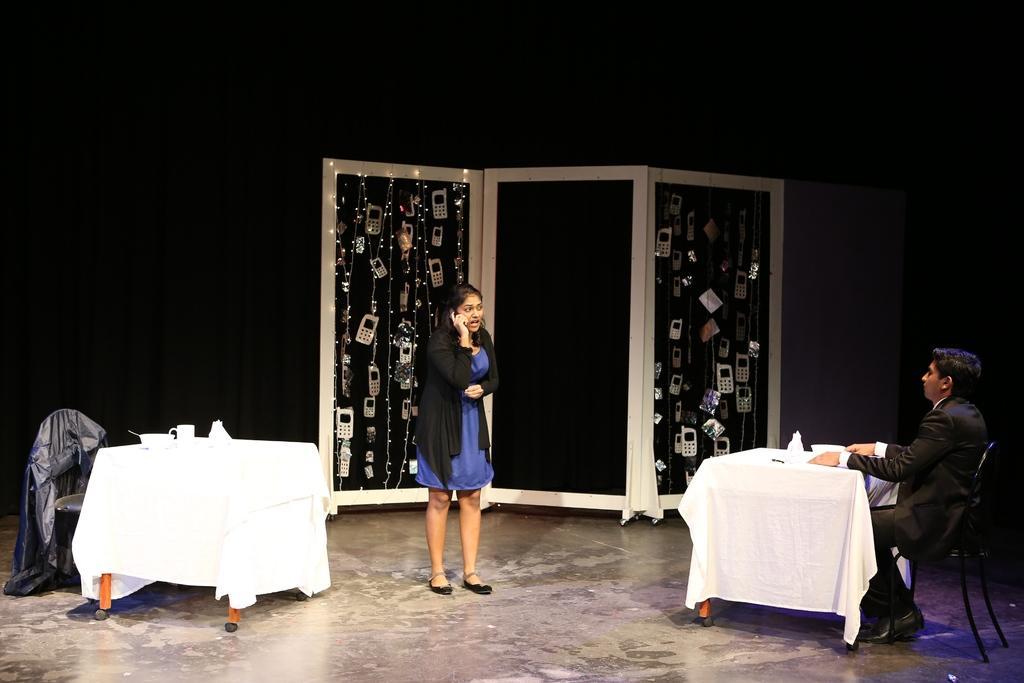Could you give a brief overview of what you see in this image? The person in the right is sitting in a chair and there is a white table in front of him and there is another person standing and speaking in mobile in front of him and there is a white table behind her and there are some mobile phones attached to a rope in the background. 